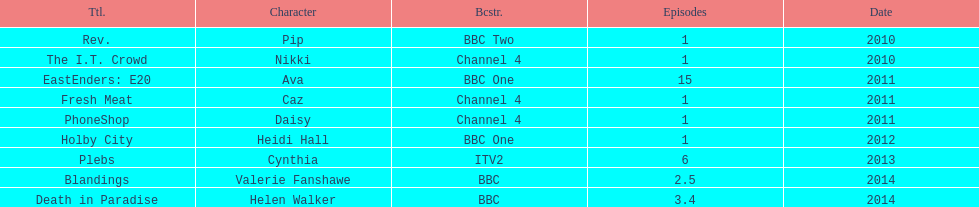Blandings and death in paradise both aired on which broadcaster? BBC. 